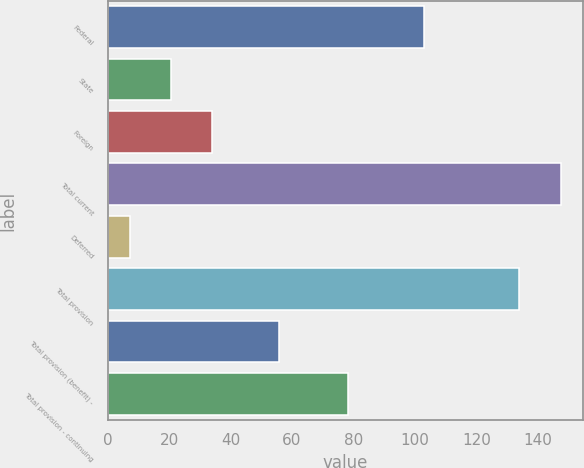<chart> <loc_0><loc_0><loc_500><loc_500><bar_chart><fcel>Federal<fcel>State<fcel>Foreign<fcel>Total current<fcel>Deferred<fcel>Total provision<fcel>Total provision (benefit) -<fcel>Total provision - continuing<nl><fcel>103<fcel>20.6<fcel>34<fcel>147.4<fcel>7.2<fcel>134<fcel>55.8<fcel>78.2<nl></chart> 